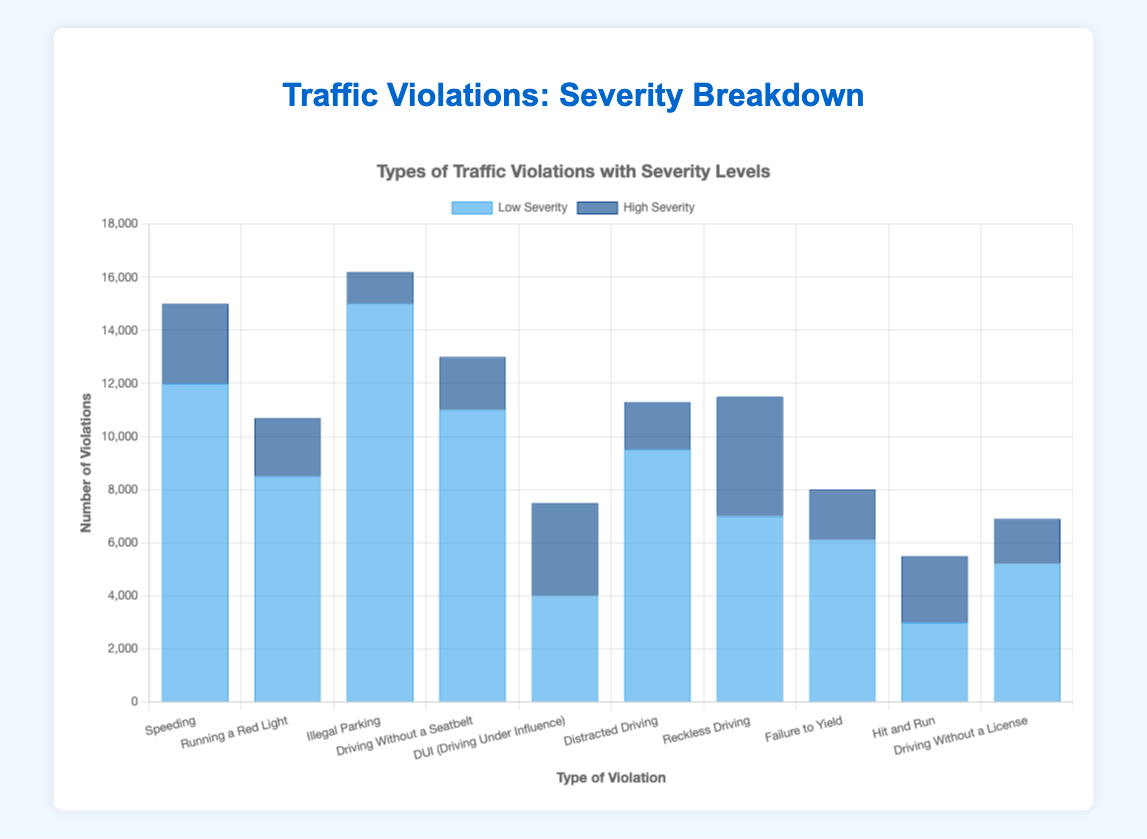What's the total number of violations for "Speeding"? The figure shows two bars for "Speeding" representing low severity and high severity violations. Adding these together: 12,000 (low) + 3,000 (high) = 15,000
Answer: 15,000 Which type of violation has the highest number of low severity incidents? By comparing the height of the blue bars for each type of violation, "Illegal Parking" has the highest count at 15,000
Answer: Illegal Parking How do the number of high severity violations for "DUI" compare to "Reckless Driving"? By comparing the dark blue bars, "Reckless Driving" has 4,500 high severity violations, which is higher compared to 3,500 for "DUI"
Answer: Reckless Driving What is the difference in the total number of violations between "Illegal Parking" and "Driving Without a License"? Summing both low and high severity violations for each: "Illegal Parking" (15,000 + 1,200 = 16,200), "Driving Without a License" (5,200 + 1,700 = 6,900). The difference is 16,200 - 6,900 = 9,300
Answer: 9,300 What's the average number of low severity violations for all violation types? Adding up all low severity counts: 12,000 + 8,500 + 15,000 + 11,000 + 4,000 + 9,500 + 7,000 + 6,100 + 3,000 + 5,200 = 81,300. There are 10 violation types, so the average is 81,300 / 10 = 8,130
Answer: 8,130 Are there more high severity or low severity violations for "Hit and Run"? "Hit and Run" has 3,000 low severity and 2,500 high severity violations, so there are more low severity violations
Answer: Low severity What's the ratio of low severity to high severity violations for "Distracted Driving"? "Distracted Driving" has 9,500 low severity and 1,800 high severity violations. The ratio is 9,500 / 1,800 = 5.28
Answer: 5.28 Which violation type has the least total number of violations? Adding total violations for each type: the lowest sum comes from "Hit and Run" with 3,000 (low) + 2,500 (high) = 5,500
Answer: Hit and Run How many high severity violations are there for traffic violations related to non-compliance with traffic signals (e.g., "Running a Red Light" and "Failure to Yield")? Summing up the high severity counts for the related violations: 2,200 (Running a Red Light) + 1,900 (Failure to Yield) = 4,100
Answer: 4,100 Explain the pattern observed in the severity distribution for "Driving Without a Seatbelt" and "DUI". Both types have significantly more low severity than high severity violations, indicating enforcement might be preventive rather than punitive for these types of violations
Answer: More low severity than high 